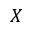Convert formula to latex. <formula><loc_0><loc_0><loc_500><loc_500>X</formula> 